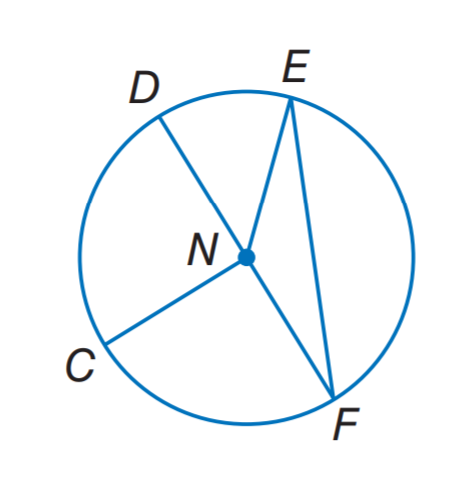Question: If C N = 8. Find D N.
Choices:
A. 4
B. 8
C. 12
D. 16
Answer with the letter. Answer: B Question: If E N = 13, what is the diameter of the circle?
Choices:
A. 6.5
B. 13
C. 19.5
D. 26
Answer with the letter. Answer: D 